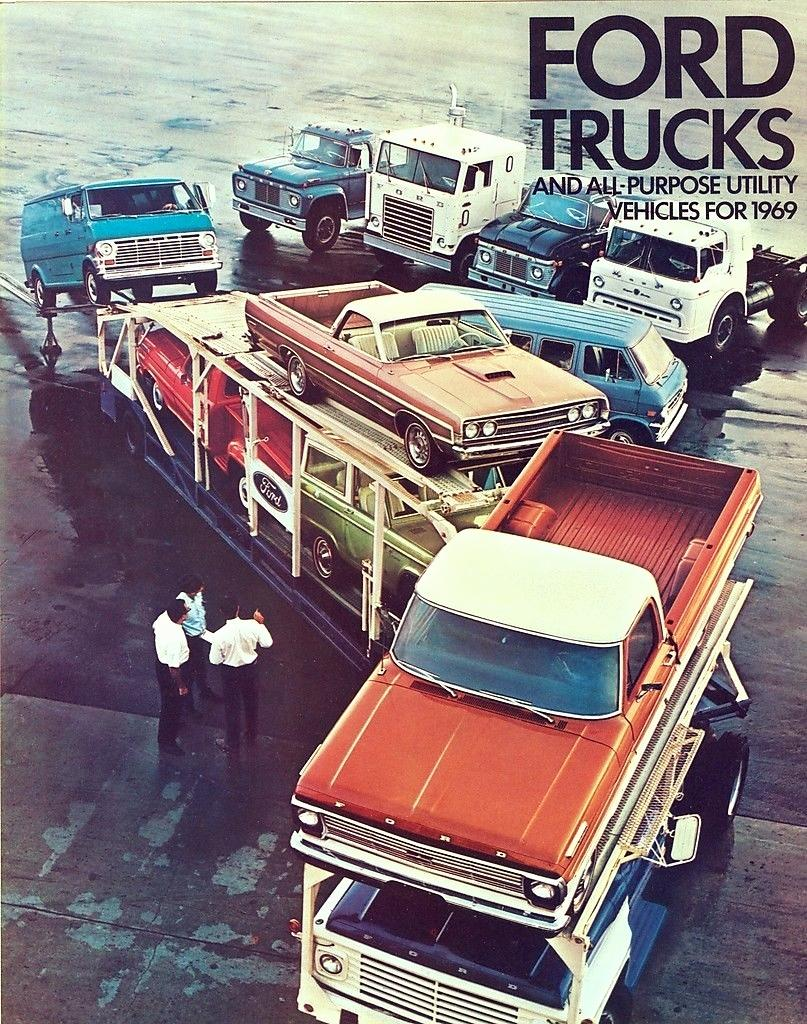What types of vehicles are in the image? There are vehicles in the image, but the specific types are not mentioned. What are the people standing beside the vehicles doing? The people are standing beside the vehicles and watching something. Can you describe the interaction between the people and the vehicles? The people are standing beside the vehicles, which suggests they might be waiting or observing something related to the vehicles. What type of plate is being used by the people to listen to something in the image? There is no plate present in the image, and the people are not using any plates to listen to something. What type of ear is being used by the people to observe something in the image? The people are not using any ears to observe something in the image; they are simply watching. What type of relation do the people have with the vehicles in the image? The specific relation between the people and the vehicles is not mentioned in the provided facts. 